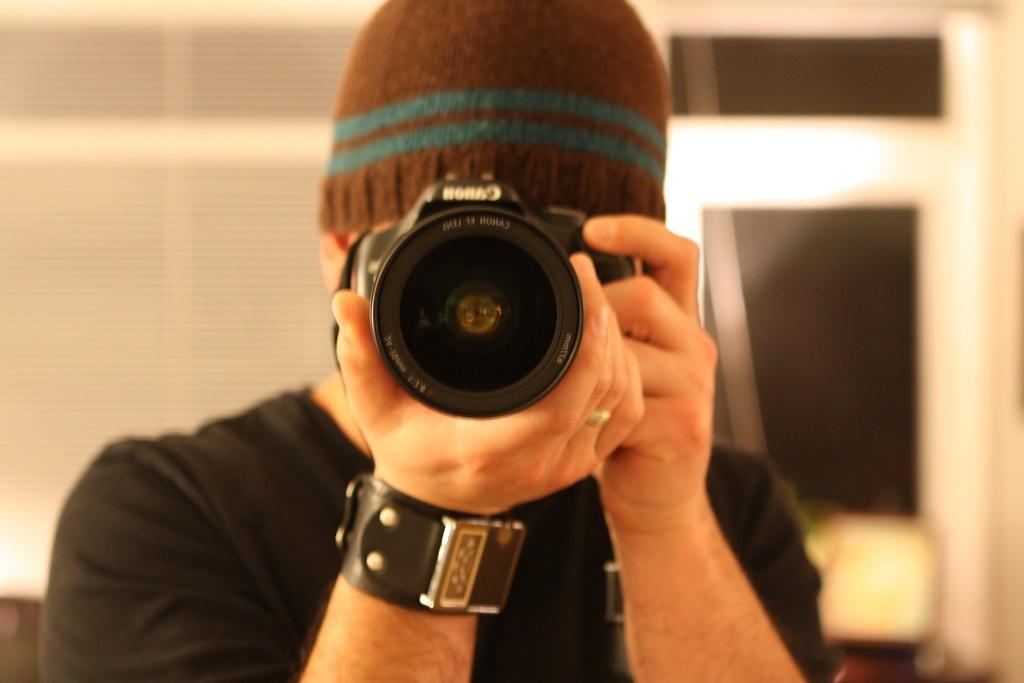Who is the main subject in the image? There is a man in the center of the image. What is the man doing in the image? The man is standing in the image. What object is the man holding in his hand? The man is holding a camera in his hand. What can be seen in the background of the image? There is a door in the background of the image. What type of flock is visible in the image? There is no flock present in the image. Is there a party happening in the image? There is no indication of a party in the image. 